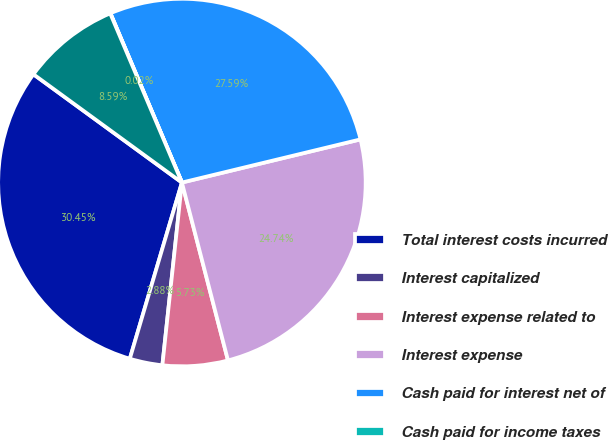Convert chart. <chart><loc_0><loc_0><loc_500><loc_500><pie_chart><fcel>Total interest costs incurred<fcel>Interest capitalized<fcel>Interest expense related to<fcel>Interest expense<fcel>Cash paid for interest net of<fcel>Cash paid for income taxes<fcel>Mortgage loans assumed with<nl><fcel>30.45%<fcel>2.88%<fcel>5.73%<fcel>24.74%<fcel>27.59%<fcel>0.02%<fcel>8.59%<nl></chart> 